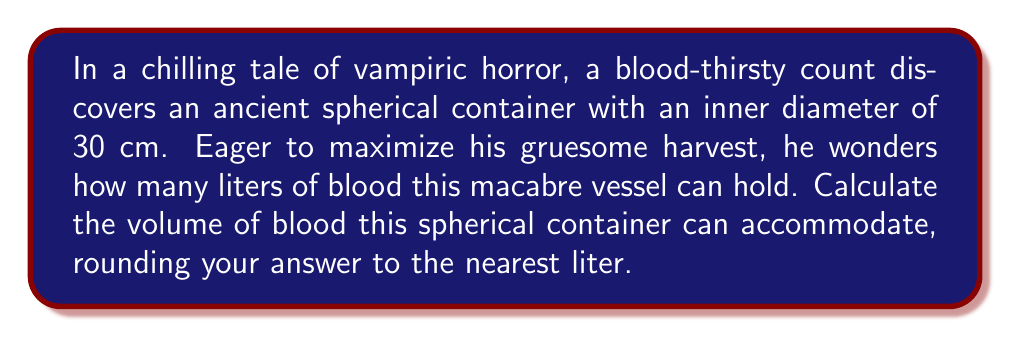Can you solve this math problem? To solve this problem, we need to follow these steps:

1) The formula for the volume of a sphere is:

   $$V = \frac{4}{3}\pi r^3$$

   where $r$ is the radius of the sphere.

2) We're given the diameter, which is 30 cm. The radius is half of this:

   $$r = \frac{30}{2} = 15 \text{ cm}$$

3) Now we can substitute this into our volume formula:

   $$V = \frac{4}{3}\pi (15)^3$$

4) Let's calculate this step by step:

   $$V = \frac{4}{3}\pi (3375)$$
   $$V = 4\pi (1125)$$
   $$V = 14137.17 \text{ cm}^3$$

5) We need to convert this to liters. 1 liter = 1000 cm³, so:

   $$14137.17 \text{ cm}^3 = 14.13717 \text{ liters}$$

6) Rounding to the nearest liter:

   $$14.13717 \text{ liters} \approx 14 \text{ liters}$$

Thus, the spherical container can hold approximately 14 liters of blood.
Answer: 14 liters 